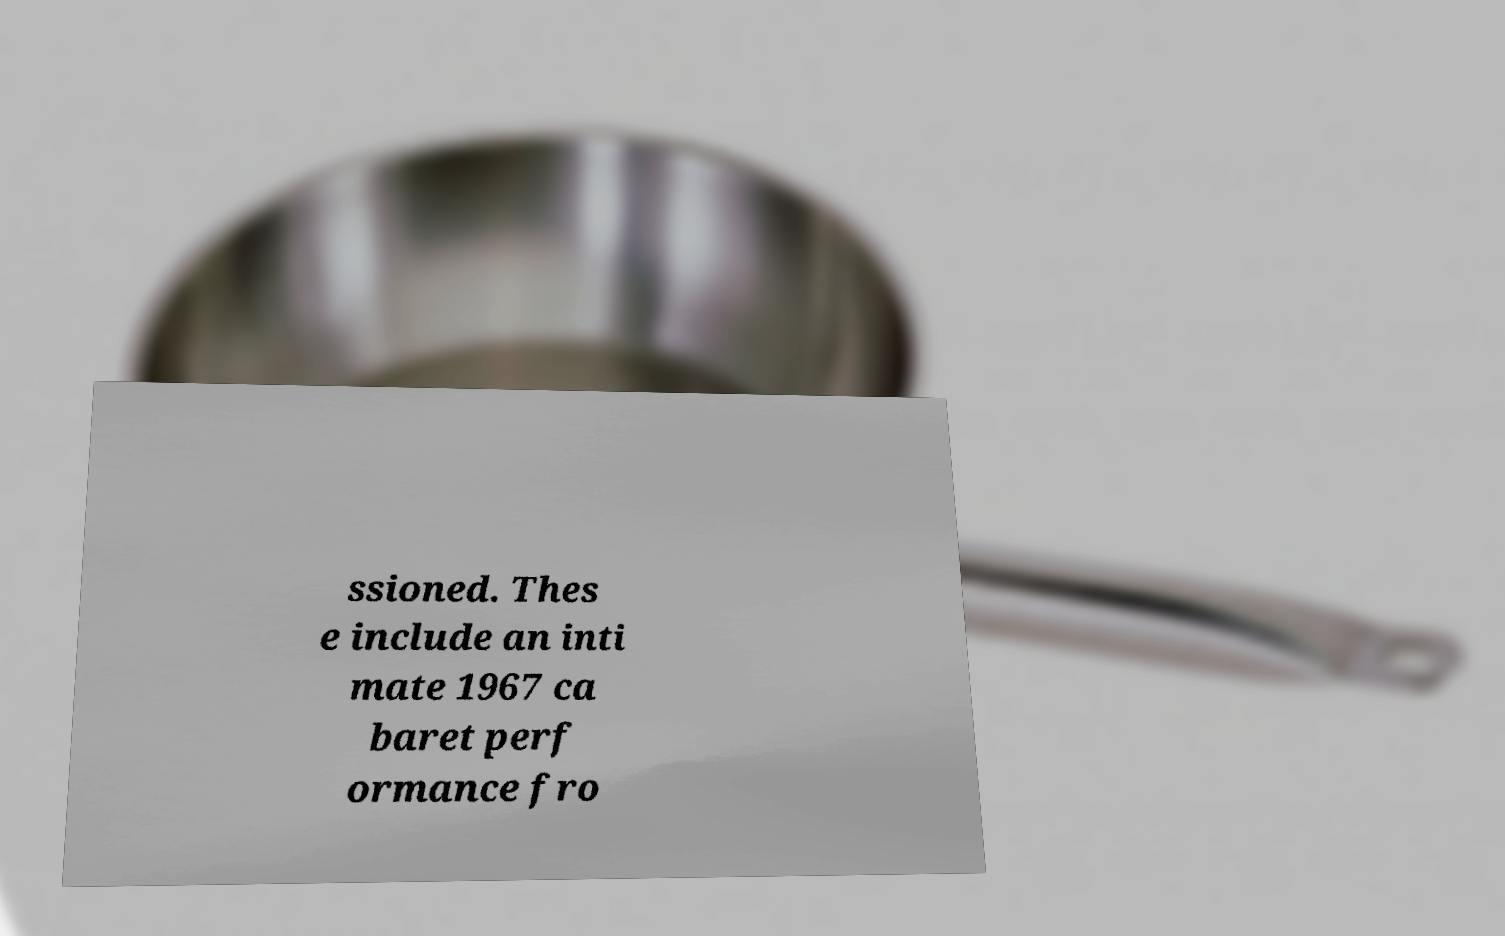What messages or text are displayed in this image? I need them in a readable, typed format. ssioned. Thes e include an inti mate 1967 ca baret perf ormance fro 